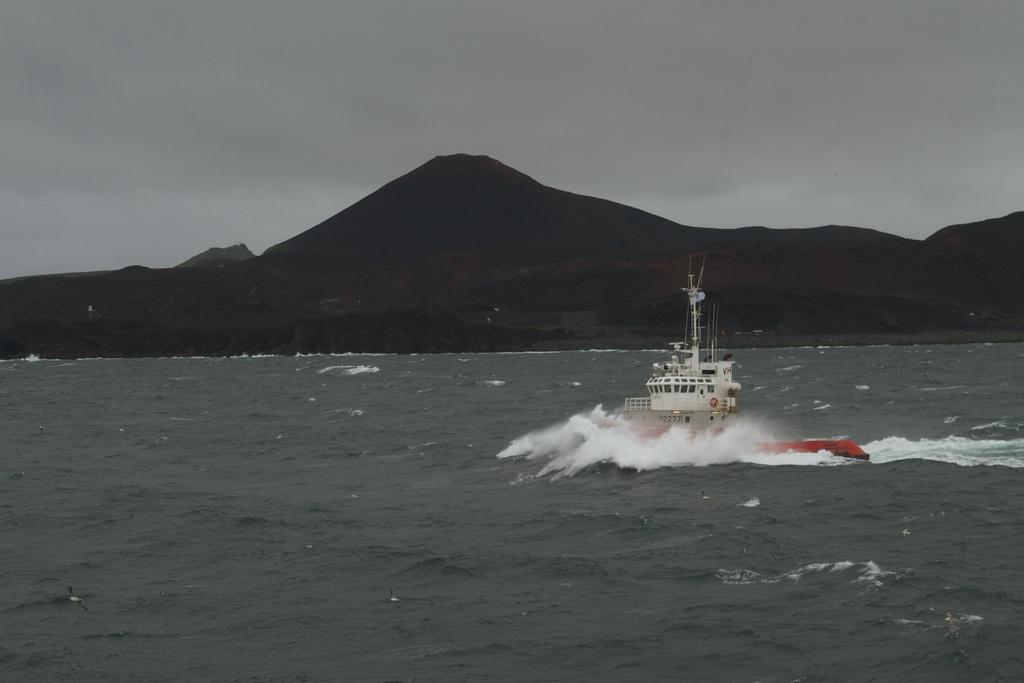Please provide a concise description of this image. In this picture there is a ship on the right side of the image, on the water and there are mountains in the background area of the image. 